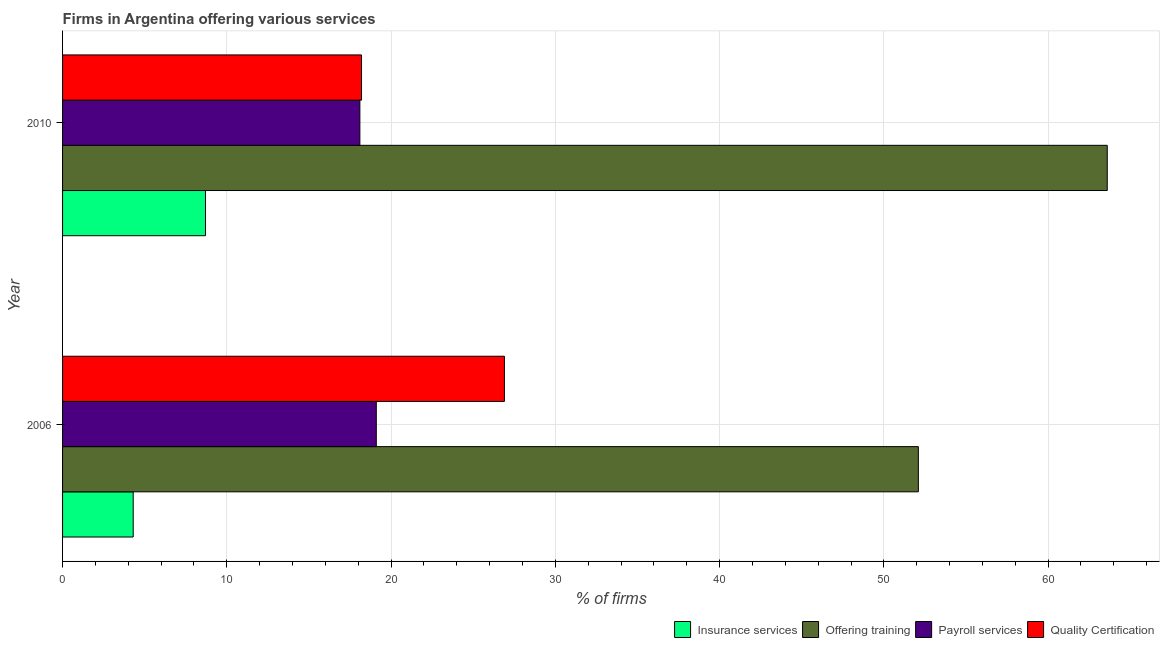How many different coloured bars are there?
Offer a very short reply. 4. How many bars are there on the 1st tick from the bottom?
Offer a very short reply. 4. What is the percentage of firms offering training in 2010?
Your answer should be compact. 63.6. Across all years, what is the maximum percentage of firms offering quality certification?
Your answer should be compact. 26.9. Across all years, what is the minimum percentage of firms offering training?
Offer a terse response. 52.1. In which year was the percentage of firms offering quality certification maximum?
Offer a very short reply. 2006. What is the total percentage of firms offering insurance services in the graph?
Provide a short and direct response. 13. What is the difference between the percentage of firms offering quality certification in 2010 and the percentage of firms offering insurance services in 2006?
Give a very brief answer. 13.9. In the year 2006, what is the difference between the percentage of firms offering training and percentage of firms offering quality certification?
Provide a short and direct response. 25.2. What is the ratio of the percentage of firms offering quality certification in 2006 to that in 2010?
Offer a very short reply. 1.48. Is the percentage of firms offering training in 2006 less than that in 2010?
Keep it short and to the point. Yes. Is the difference between the percentage of firms offering insurance services in 2006 and 2010 greater than the difference between the percentage of firms offering payroll services in 2006 and 2010?
Give a very brief answer. No. Is it the case that in every year, the sum of the percentage of firms offering training and percentage of firms offering payroll services is greater than the sum of percentage of firms offering quality certification and percentage of firms offering insurance services?
Provide a succinct answer. Yes. What does the 4th bar from the top in 2006 represents?
Your response must be concise. Insurance services. What does the 1st bar from the bottom in 2010 represents?
Keep it short and to the point. Insurance services. How many bars are there?
Your answer should be very brief. 8. Are all the bars in the graph horizontal?
Provide a succinct answer. Yes. How many years are there in the graph?
Your response must be concise. 2. Does the graph contain any zero values?
Give a very brief answer. No. Where does the legend appear in the graph?
Your answer should be very brief. Bottom right. How are the legend labels stacked?
Provide a succinct answer. Horizontal. What is the title of the graph?
Make the answer very short. Firms in Argentina offering various services . What is the label or title of the X-axis?
Ensure brevity in your answer.  % of firms. What is the label or title of the Y-axis?
Offer a terse response. Year. What is the % of firms of Offering training in 2006?
Your response must be concise. 52.1. What is the % of firms in Payroll services in 2006?
Give a very brief answer. 19.1. What is the % of firms in Quality Certification in 2006?
Provide a succinct answer. 26.9. What is the % of firms of Insurance services in 2010?
Your answer should be compact. 8.7. What is the % of firms in Offering training in 2010?
Offer a very short reply. 63.6. Across all years, what is the maximum % of firms of Offering training?
Provide a succinct answer. 63.6. Across all years, what is the maximum % of firms of Quality Certification?
Your answer should be very brief. 26.9. Across all years, what is the minimum % of firms of Insurance services?
Keep it short and to the point. 4.3. Across all years, what is the minimum % of firms of Offering training?
Provide a short and direct response. 52.1. Across all years, what is the minimum % of firms in Payroll services?
Provide a short and direct response. 18.1. What is the total % of firms of Insurance services in the graph?
Keep it short and to the point. 13. What is the total % of firms of Offering training in the graph?
Your response must be concise. 115.7. What is the total % of firms of Payroll services in the graph?
Keep it short and to the point. 37.2. What is the total % of firms of Quality Certification in the graph?
Keep it short and to the point. 45.1. What is the difference between the % of firms of Insurance services in 2006 and that in 2010?
Provide a succinct answer. -4.4. What is the difference between the % of firms of Payroll services in 2006 and that in 2010?
Your answer should be very brief. 1. What is the difference between the % of firms of Quality Certification in 2006 and that in 2010?
Make the answer very short. 8.7. What is the difference between the % of firms in Insurance services in 2006 and the % of firms in Offering training in 2010?
Make the answer very short. -59.3. What is the difference between the % of firms in Insurance services in 2006 and the % of firms in Quality Certification in 2010?
Offer a very short reply. -13.9. What is the difference between the % of firms of Offering training in 2006 and the % of firms of Quality Certification in 2010?
Provide a short and direct response. 33.9. What is the difference between the % of firms in Payroll services in 2006 and the % of firms in Quality Certification in 2010?
Ensure brevity in your answer.  0.9. What is the average % of firms of Offering training per year?
Provide a succinct answer. 57.85. What is the average % of firms in Quality Certification per year?
Ensure brevity in your answer.  22.55. In the year 2006, what is the difference between the % of firms in Insurance services and % of firms in Offering training?
Offer a very short reply. -47.8. In the year 2006, what is the difference between the % of firms in Insurance services and % of firms in Payroll services?
Make the answer very short. -14.8. In the year 2006, what is the difference between the % of firms in Insurance services and % of firms in Quality Certification?
Offer a terse response. -22.6. In the year 2006, what is the difference between the % of firms of Offering training and % of firms of Quality Certification?
Your answer should be very brief. 25.2. In the year 2006, what is the difference between the % of firms in Payroll services and % of firms in Quality Certification?
Provide a succinct answer. -7.8. In the year 2010, what is the difference between the % of firms of Insurance services and % of firms of Offering training?
Provide a short and direct response. -54.9. In the year 2010, what is the difference between the % of firms in Insurance services and % of firms in Quality Certification?
Make the answer very short. -9.5. In the year 2010, what is the difference between the % of firms in Offering training and % of firms in Payroll services?
Your answer should be compact. 45.5. In the year 2010, what is the difference between the % of firms in Offering training and % of firms in Quality Certification?
Your answer should be very brief. 45.4. What is the ratio of the % of firms in Insurance services in 2006 to that in 2010?
Offer a terse response. 0.49. What is the ratio of the % of firms in Offering training in 2006 to that in 2010?
Offer a terse response. 0.82. What is the ratio of the % of firms in Payroll services in 2006 to that in 2010?
Offer a terse response. 1.06. What is the ratio of the % of firms of Quality Certification in 2006 to that in 2010?
Provide a succinct answer. 1.48. What is the difference between the highest and the second highest % of firms of Offering training?
Your answer should be compact. 11.5. What is the difference between the highest and the second highest % of firms of Payroll services?
Give a very brief answer. 1. What is the difference between the highest and the lowest % of firms of Offering training?
Provide a succinct answer. 11.5. 